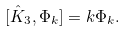Convert formula to latex. <formula><loc_0><loc_0><loc_500><loc_500>[ \hat { K } _ { 3 } , \Phi _ { k } ] = k \Phi _ { k } .</formula> 